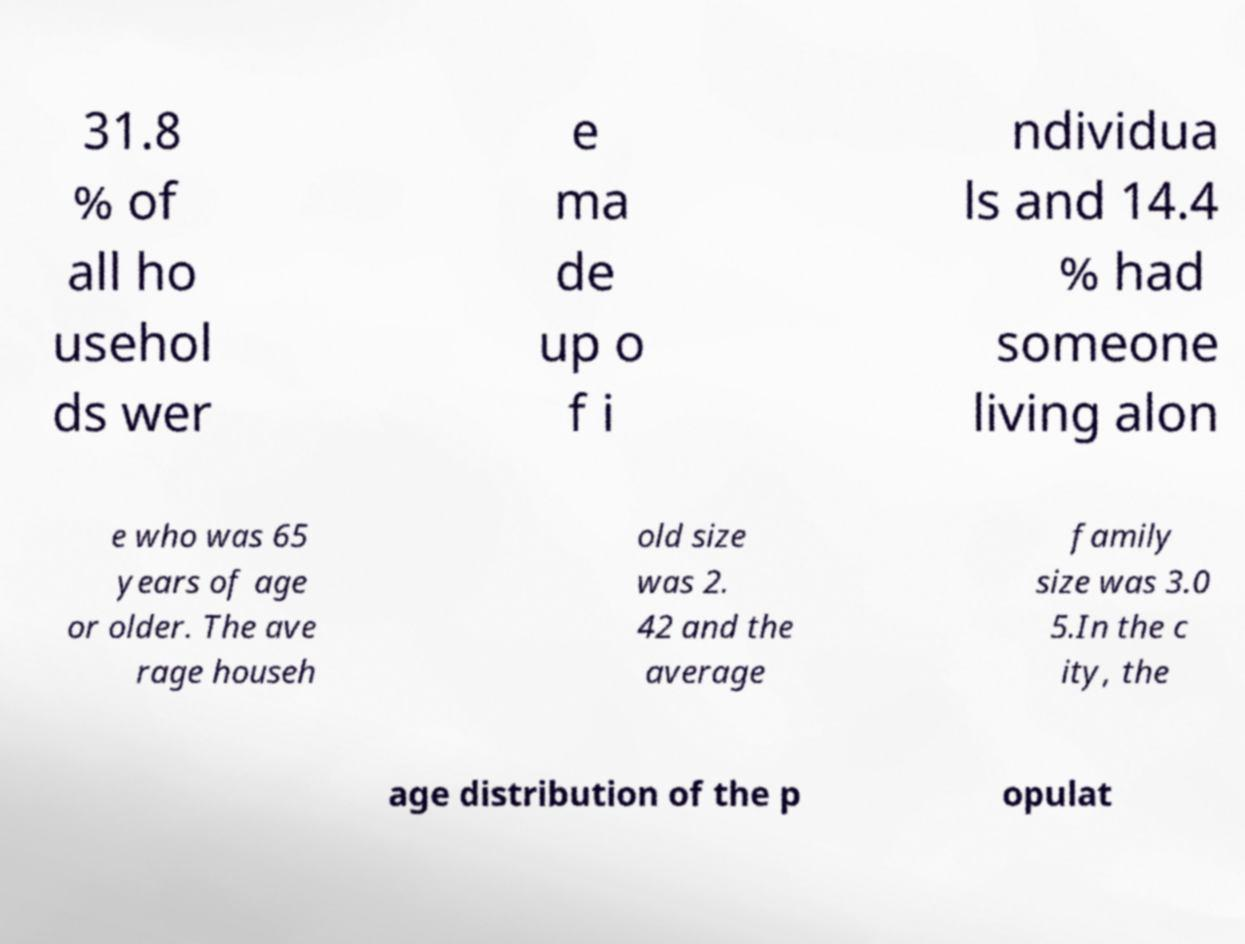For documentation purposes, I need the text within this image transcribed. Could you provide that? 31.8 % of all ho usehol ds wer e ma de up o f i ndividua ls and 14.4 % had someone living alon e who was 65 years of age or older. The ave rage househ old size was 2. 42 and the average family size was 3.0 5.In the c ity, the age distribution of the p opulat 